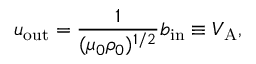<formula> <loc_0><loc_0><loc_500><loc_500>u _ { o u t } = \frac { 1 } { ( \mu _ { 0 } \rho _ { 0 } ) ^ { 1 / 2 } } b _ { i n } \equiv V _ { A } ,</formula> 